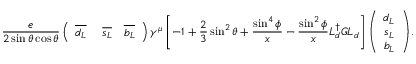Convert formula to latex. <formula><loc_0><loc_0><loc_500><loc_500>\frac { e } 2 \sin \theta \cos \theta } \left ( \begin{array} { c c c } { { \overline { { { d _ { L } } } } } } & { { \ \overline { { { s _ { L } } } } } } & { { \overline { { { b _ { L } } } } } } \end{array} \right ) \gamma ^ { \mu } \left [ - 1 + \frac { 2 } { 3 } \sin ^ { 2 } \theta + \frac { \sin ^ { 4 } \phi } x - \frac { \sin ^ { 2 } \phi } x L _ { d } ^ { \dagger } G L _ { d } \right ] \left ( \begin{array} { c } { { d _ { L } } } \\ { { s _ { L } } } \\ { { b _ { L } } } \end{array} \right ) Z _ { \mu } \, ,</formula> 